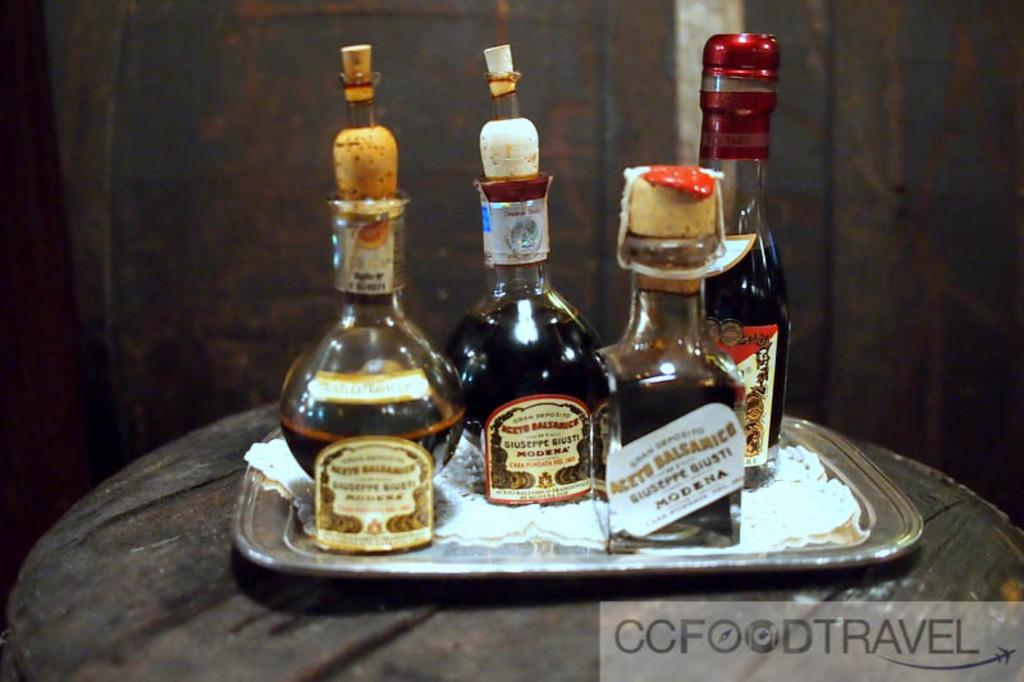Provide a one-sentence caption for the provided image. Various small bottle of Modena alcohol for CCFoodTravel. 